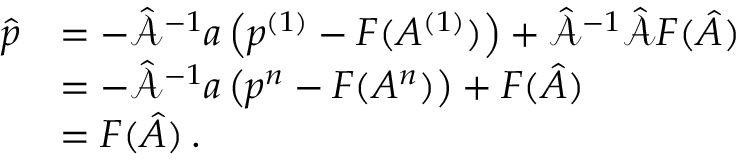Convert formula to latex. <formula><loc_0><loc_0><loc_500><loc_500>\begin{array} { r l } { \hat { p } } & { = - \hat { \mathcal { A } } ^ { - 1 } a \left ( p ^ { ( 1 ) } - F ( A ^ { ( 1 ) } ) \right ) + \hat { \mathcal { A } } ^ { - 1 } \hat { \mathcal { A } } F ( \hat { A } ) \, } \\ & { = - \hat { \mathcal { A } } ^ { - 1 } a \left ( p ^ { n } - F ( A ^ { n } ) \right ) + F ( \hat { A } ) \, } \\ & { = F ( \hat { A } ) \, . } \end{array}</formula> 